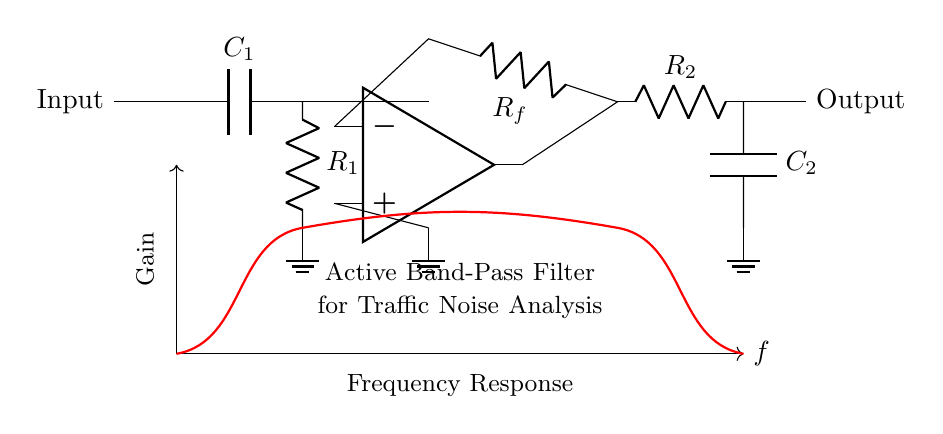What are the components in the high-pass filter section? The high-pass filter section includes a capacitor labeled C1 and a resistor labeled R1. These components work together to allow higher frequencies to pass while attenuating lower frequencies.
Answer: C1, R1 What is the function of the op-amp in this circuit? The operational amplifier (op-amp) is used to amplify the signal coming from the high-pass filter while providing negative feedback through the resistor Rf. This configuration helps maintain stable gain and allows for a band-pass filter effect.
Answer: Amplification What is the role of the capacitor C2 in the low-pass filter section? Capacitor C2 is used in conjunction with resistor R2 to create a low-pass filter that allows low frequencies to pass while attenuating higher frequencies. When connected in this way, it combines with the high-pass section to form a band-pass filter.
Answer: Low-pass filter How are the filters connected in this circuit? The high-pass filter section is connected in series with the operational amplifier, which in turn connects to the low-pass filter section. This series arrangement creates a band-pass filter effect by isolating a specific frequency range.
Answer: Series What is the expected frequency response of this circuit? The frequency response shows a peak in gain at a specific frequency range, indicating that this active band-pass filter is tuned to allow traffic noise signals within that range to pass through while attenuating others.
Answer: Band-pass 